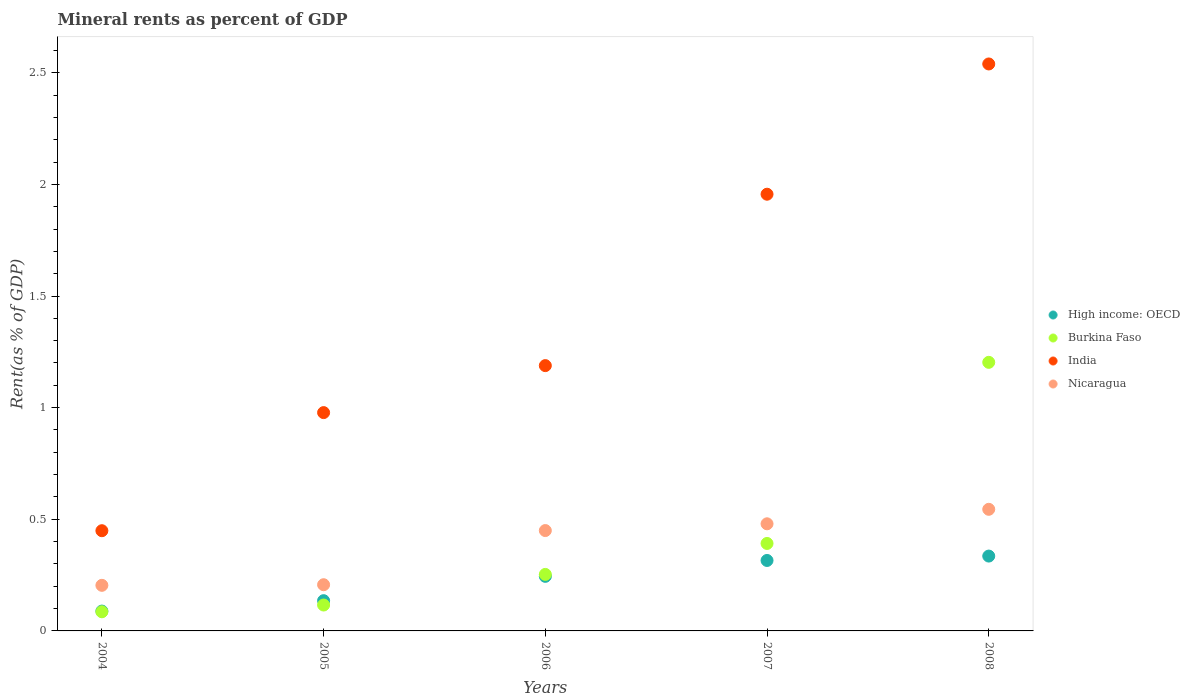Is the number of dotlines equal to the number of legend labels?
Ensure brevity in your answer.  Yes. What is the mineral rent in India in 2007?
Keep it short and to the point. 1.96. Across all years, what is the maximum mineral rent in Nicaragua?
Provide a short and direct response. 0.54. Across all years, what is the minimum mineral rent in High income: OECD?
Your answer should be very brief. 0.09. In which year was the mineral rent in India maximum?
Give a very brief answer. 2008. What is the total mineral rent in Nicaragua in the graph?
Offer a very short reply. 1.89. What is the difference between the mineral rent in High income: OECD in 2004 and that in 2008?
Offer a very short reply. -0.25. What is the difference between the mineral rent in Burkina Faso in 2004 and the mineral rent in Nicaragua in 2007?
Your answer should be very brief. -0.39. What is the average mineral rent in High income: OECD per year?
Make the answer very short. 0.22. In the year 2006, what is the difference between the mineral rent in Nicaragua and mineral rent in India?
Your answer should be compact. -0.74. In how many years, is the mineral rent in Nicaragua greater than 1.7 %?
Keep it short and to the point. 0. What is the ratio of the mineral rent in High income: OECD in 2004 to that in 2008?
Offer a very short reply. 0.27. Is the mineral rent in India in 2005 less than that in 2007?
Your answer should be very brief. Yes. What is the difference between the highest and the second highest mineral rent in Nicaragua?
Give a very brief answer. 0.06. What is the difference between the highest and the lowest mineral rent in High income: OECD?
Offer a terse response. 0.25. Is it the case that in every year, the sum of the mineral rent in Nicaragua and mineral rent in Burkina Faso  is greater than the mineral rent in India?
Provide a succinct answer. No. Does the mineral rent in India monotonically increase over the years?
Provide a succinct answer. Yes. Is the mineral rent in High income: OECD strictly less than the mineral rent in India over the years?
Keep it short and to the point. Yes. What is the difference between two consecutive major ticks on the Y-axis?
Offer a very short reply. 0.5. Are the values on the major ticks of Y-axis written in scientific E-notation?
Your answer should be compact. No. Where does the legend appear in the graph?
Your answer should be very brief. Center right. How many legend labels are there?
Offer a terse response. 4. How are the legend labels stacked?
Offer a terse response. Vertical. What is the title of the graph?
Your answer should be compact. Mineral rents as percent of GDP. What is the label or title of the X-axis?
Your answer should be compact. Years. What is the label or title of the Y-axis?
Provide a short and direct response. Rent(as % of GDP). What is the Rent(as % of GDP) in High income: OECD in 2004?
Keep it short and to the point. 0.09. What is the Rent(as % of GDP) in Burkina Faso in 2004?
Offer a terse response. 0.09. What is the Rent(as % of GDP) of India in 2004?
Your answer should be compact. 0.45. What is the Rent(as % of GDP) in Nicaragua in 2004?
Your response must be concise. 0.2. What is the Rent(as % of GDP) of High income: OECD in 2005?
Provide a short and direct response. 0.14. What is the Rent(as % of GDP) of Burkina Faso in 2005?
Offer a terse response. 0.12. What is the Rent(as % of GDP) of India in 2005?
Ensure brevity in your answer.  0.98. What is the Rent(as % of GDP) of Nicaragua in 2005?
Ensure brevity in your answer.  0.21. What is the Rent(as % of GDP) in High income: OECD in 2006?
Your answer should be compact. 0.24. What is the Rent(as % of GDP) in Burkina Faso in 2006?
Your response must be concise. 0.25. What is the Rent(as % of GDP) in India in 2006?
Offer a terse response. 1.19. What is the Rent(as % of GDP) of Nicaragua in 2006?
Your answer should be compact. 0.45. What is the Rent(as % of GDP) in High income: OECD in 2007?
Keep it short and to the point. 0.32. What is the Rent(as % of GDP) in Burkina Faso in 2007?
Make the answer very short. 0.39. What is the Rent(as % of GDP) in India in 2007?
Ensure brevity in your answer.  1.96. What is the Rent(as % of GDP) in Nicaragua in 2007?
Offer a terse response. 0.48. What is the Rent(as % of GDP) in High income: OECD in 2008?
Give a very brief answer. 0.34. What is the Rent(as % of GDP) in Burkina Faso in 2008?
Ensure brevity in your answer.  1.2. What is the Rent(as % of GDP) in India in 2008?
Make the answer very short. 2.54. What is the Rent(as % of GDP) of Nicaragua in 2008?
Offer a terse response. 0.54. Across all years, what is the maximum Rent(as % of GDP) in High income: OECD?
Provide a short and direct response. 0.34. Across all years, what is the maximum Rent(as % of GDP) of Burkina Faso?
Provide a short and direct response. 1.2. Across all years, what is the maximum Rent(as % of GDP) of India?
Make the answer very short. 2.54. Across all years, what is the maximum Rent(as % of GDP) of Nicaragua?
Your answer should be compact. 0.54. Across all years, what is the minimum Rent(as % of GDP) in High income: OECD?
Keep it short and to the point. 0.09. Across all years, what is the minimum Rent(as % of GDP) in Burkina Faso?
Offer a terse response. 0.09. Across all years, what is the minimum Rent(as % of GDP) of India?
Your answer should be very brief. 0.45. Across all years, what is the minimum Rent(as % of GDP) in Nicaragua?
Offer a terse response. 0.2. What is the total Rent(as % of GDP) of High income: OECD in the graph?
Provide a short and direct response. 1.12. What is the total Rent(as % of GDP) of Burkina Faso in the graph?
Give a very brief answer. 2.05. What is the total Rent(as % of GDP) of India in the graph?
Make the answer very short. 7.11. What is the total Rent(as % of GDP) in Nicaragua in the graph?
Your answer should be compact. 1.89. What is the difference between the Rent(as % of GDP) of High income: OECD in 2004 and that in 2005?
Offer a terse response. -0.05. What is the difference between the Rent(as % of GDP) in Burkina Faso in 2004 and that in 2005?
Provide a short and direct response. -0.03. What is the difference between the Rent(as % of GDP) of India in 2004 and that in 2005?
Keep it short and to the point. -0.53. What is the difference between the Rent(as % of GDP) in Nicaragua in 2004 and that in 2005?
Offer a terse response. -0. What is the difference between the Rent(as % of GDP) of High income: OECD in 2004 and that in 2006?
Keep it short and to the point. -0.16. What is the difference between the Rent(as % of GDP) of Burkina Faso in 2004 and that in 2006?
Provide a short and direct response. -0.17. What is the difference between the Rent(as % of GDP) in India in 2004 and that in 2006?
Make the answer very short. -0.74. What is the difference between the Rent(as % of GDP) in Nicaragua in 2004 and that in 2006?
Provide a succinct answer. -0.25. What is the difference between the Rent(as % of GDP) of High income: OECD in 2004 and that in 2007?
Your answer should be compact. -0.23. What is the difference between the Rent(as % of GDP) of Burkina Faso in 2004 and that in 2007?
Provide a succinct answer. -0.31. What is the difference between the Rent(as % of GDP) of India in 2004 and that in 2007?
Offer a terse response. -1.51. What is the difference between the Rent(as % of GDP) in Nicaragua in 2004 and that in 2007?
Your answer should be very brief. -0.28. What is the difference between the Rent(as % of GDP) of High income: OECD in 2004 and that in 2008?
Ensure brevity in your answer.  -0.25. What is the difference between the Rent(as % of GDP) of Burkina Faso in 2004 and that in 2008?
Your answer should be very brief. -1.12. What is the difference between the Rent(as % of GDP) in India in 2004 and that in 2008?
Provide a short and direct response. -2.09. What is the difference between the Rent(as % of GDP) in Nicaragua in 2004 and that in 2008?
Ensure brevity in your answer.  -0.34. What is the difference between the Rent(as % of GDP) in High income: OECD in 2005 and that in 2006?
Keep it short and to the point. -0.11. What is the difference between the Rent(as % of GDP) in Burkina Faso in 2005 and that in 2006?
Your answer should be compact. -0.14. What is the difference between the Rent(as % of GDP) of India in 2005 and that in 2006?
Your response must be concise. -0.21. What is the difference between the Rent(as % of GDP) in Nicaragua in 2005 and that in 2006?
Ensure brevity in your answer.  -0.24. What is the difference between the Rent(as % of GDP) of High income: OECD in 2005 and that in 2007?
Your answer should be compact. -0.18. What is the difference between the Rent(as % of GDP) of Burkina Faso in 2005 and that in 2007?
Your response must be concise. -0.28. What is the difference between the Rent(as % of GDP) in India in 2005 and that in 2007?
Offer a very short reply. -0.98. What is the difference between the Rent(as % of GDP) of Nicaragua in 2005 and that in 2007?
Your response must be concise. -0.27. What is the difference between the Rent(as % of GDP) in High income: OECD in 2005 and that in 2008?
Your response must be concise. -0.2. What is the difference between the Rent(as % of GDP) of Burkina Faso in 2005 and that in 2008?
Keep it short and to the point. -1.09. What is the difference between the Rent(as % of GDP) of India in 2005 and that in 2008?
Keep it short and to the point. -1.56. What is the difference between the Rent(as % of GDP) in Nicaragua in 2005 and that in 2008?
Keep it short and to the point. -0.34. What is the difference between the Rent(as % of GDP) of High income: OECD in 2006 and that in 2007?
Make the answer very short. -0.07. What is the difference between the Rent(as % of GDP) of Burkina Faso in 2006 and that in 2007?
Your answer should be compact. -0.14. What is the difference between the Rent(as % of GDP) in India in 2006 and that in 2007?
Your answer should be compact. -0.77. What is the difference between the Rent(as % of GDP) in Nicaragua in 2006 and that in 2007?
Ensure brevity in your answer.  -0.03. What is the difference between the Rent(as % of GDP) of High income: OECD in 2006 and that in 2008?
Make the answer very short. -0.09. What is the difference between the Rent(as % of GDP) in Burkina Faso in 2006 and that in 2008?
Keep it short and to the point. -0.95. What is the difference between the Rent(as % of GDP) in India in 2006 and that in 2008?
Your answer should be very brief. -1.35. What is the difference between the Rent(as % of GDP) in Nicaragua in 2006 and that in 2008?
Your answer should be very brief. -0.1. What is the difference between the Rent(as % of GDP) in High income: OECD in 2007 and that in 2008?
Your response must be concise. -0.02. What is the difference between the Rent(as % of GDP) of Burkina Faso in 2007 and that in 2008?
Give a very brief answer. -0.81. What is the difference between the Rent(as % of GDP) in India in 2007 and that in 2008?
Your response must be concise. -0.58. What is the difference between the Rent(as % of GDP) of Nicaragua in 2007 and that in 2008?
Provide a short and direct response. -0.06. What is the difference between the Rent(as % of GDP) in High income: OECD in 2004 and the Rent(as % of GDP) in Burkina Faso in 2005?
Your response must be concise. -0.03. What is the difference between the Rent(as % of GDP) of High income: OECD in 2004 and the Rent(as % of GDP) of India in 2005?
Keep it short and to the point. -0.89. What is the difference between the Rent(as % of GDP) of High income: OECD in 2004 and the Rent(as % of GDP) of Nicaragua in 2005?
Provide a short and direct response. -0.12. What is the difference between the Rent(as % of GDP) of Burkina Faso in 2004 and the Rent(as % of GDP) of India in 2005?
Your answer should be compact. -0.89. What is the difference between the Rent(as % of GDP) in Burkina Faso in 2004 and the Rent(as % of GDP) in Nicaragua in 2005?
Your answer should be compact. -0.12. What is the difference between the Rent(as % of GDP) of India in 2004 and the Rent(as % of GDP) of Nicaragua in 2005?
Your answer should be compact. 0.24. What is the difference between the Rent(as % of GDP) in High income: OECD in 2004 and the Rent(as % of GDP) in Burkina Faso in 2006?
Offer a very short reply. -0.16. What is the difference between the Rent(as % of GDP) of High income: OECD in 2004 and the Rent(as % of GDP) of India in 2006?
Offer a terse response. -1.1. What is the difference between the Rent(as % of GDP) in High income: OECD in 2004 and the Rent(as % of GDP) in Nicaragua in 2006?
Offer a terse response. -0.36. What is the difference between the Rent(as % of GDP) of Burkina Faso in 2004 and the Rent(as % of GDP) of India in 2006?
Provide a succinct answer. -1.1. What is the difference between the Rent(as % of GDP) in Burkina Faso in 2004 and the Rent(as % of GDP) in Nicaragua in 2006?
Give a very brief answer. -0.36. What is the difference between the Rent(as % of GDP) in India in 2004 and the Rent(as % of GDP) in Nicaragua in 2006?
Provide a succinct answer. -0. What is the difference between the Rent(as % of GDP) in High income: OECD in 2004 and the Rent(as % of GDP) in Burkina Faso in 2007?
Make the answer very short. -0.3. What is the difference between the Rent(as % of GDP) in High income: OECD in 2004 and the Rent(as % of GDP) in India in 2007?
Ensure brevity in your answer.  -1.87. What is the difference between the Rent(as % of GDP) in High income: OECD in 2004 and the Rent(as % of GDP) in Nicaragua in 2007?
Keep it short and to the point. -0.39. What is the difference between the Rent(as % of GDP) in Burkina Faso in 2004 and the Rent(as % of GDP) in India in 2007?
Keep it short and to the point. -1.87. What is the difference between the Rent(as % of GDP) in Burkina Faso in 2004 and the Rent(as % of GDP) in Nicaragua in 2007?
Offer a very short reply. -0.39. What is the difference between the Rent(as % of GDP) of India in 2004 and the Rent(as % of GDP) of Nicaragua in 2007?
Your answer should be compact. -0.03. What is the difference between the Rent(as % of GDP) of High income: OECD in 2004 and the Rent(as % of GDP) of Burkina Faso in 2008?
Offer a terse response. -1.11. What is the difference between the Rent(as % of GDP) in High income: OECD in 2004 and the Rent(as % of GDP) in India in 2008?
Provide a succinct answer. -2.45. What is the difference between the Rent(as % of GDP) in High income: OECD in 2004 and the Rent(as % of GDP) in Nicaragua in 2008?
Keep it short and to the point. -0.46. What is the difference between the Rent(as % of GDP) of Burkina Faso in 2004 and the Rent(as % of GDP) of India in 2008?
Provide a short and direct response. -2.45. What is the difference between the Rent(as % of GDP) of Burkina Faso in 2004 and the Rent(as % of GDP) of Nicaragua in 2008?
Your answer should be very brief. -0.46. What is the difference between the Rent(as % of GDP) in India in 2004 and the Rent(as % of GDP) in Nicaragua in 2008?
Your answer should be very brief. -0.1. What is the difference between the Rent(as % of GDP) in High income: OECD in 2005 and the Rent(as % of GDP) in Burkina Faso in 2006?
Keep it short and to the point. -0.12. What is the difference between the Rent(as % of GDP) of High income: OECD in 2005 and the Rent(as % of GDP) of India in 2006?
Offer a very short reply. -1.05. What is the difference between the Rent(as % of GDP) in High income: OECD in 2005 and the Rent(as % of GDP) in Nicaragua in 2006?
Provide a succinct answer. -0.31. What is the difference between the Rent(as % of GDP) in Burkina Faso in 2005 and the Rent(as % of GDP) in India in 2006?
Your answer should be very brief. -1.07. What is the difference between the Rent(as % of GDP) of Burkina Faso in 2005 and the Rent(as % of GDP) of Nicaragua in 2006?
Provide a succinct answer. -0.33. What is the difference between the Rent(as % of GDP) of India in 2005 and the Rent(as % of GDP) of Nicaragua in 2006?
Give a very brief answer. 0.53. What is the difference between the Rent(as % of GDP) of High income: OECD in 2005 and the Rent(as % of GDP) of Burkina Faso in 2007?
Make the answer very short. -0.26. What is the difference between the Rent(as % of GDP) in High income: OECD in 2005 and the Rent(as % of GDP) in India in 2007?
Give a very brief answer. -1.82. What is the difference between the Rent(as % of GDP) of High income: OECD in 2005 and the Rent(as % of GDP) of Nicaragua in 2007?
Offer a terse response. -0.34. What is the difference between the Rent(as % of GDP) in Burkina Faso in 2005 and the Rent(as % of GDP) in India in 2007?
Your answer should be very brief. -1.84. What is the difference between the Rent(as % of GDP) in Burkina Faso in 2005 and the Rent(as % of GDP) in Nicaragua in 2007?
Your answer should be very brief. -0.36. What is the difference between the Rent(as % of GDP) of India in 2005 and the Rent(as % of GDP) of Nicaragua in 2007?
Provide a succinct answer. 0.5. What is the difference between the Rent(as % of GDP) of High income: OECD in 2005 and the Rent(as % of GDP) of Burkina Faso in 2008?
Keep it short and to the point. -1.07. What is the difference between the Rent(as % of GDP) in High income: OECD in 2005 and the Rent(as % of GDP) in India in 2008?
Offer a very short reply. -2.4. What is the difference between the Rent(as % of GDP) of High income: OECD in 2005 and the Rent(as % of GDP) of Nicaragua in 2008?
Ensure brevity in your answer.  -0.41. What is the difference between the Rent(as % of GDP) in Burkina Faso in 2005 and the Rent(as % of GDP) in India in 2008?
Provide a short and direct response. -2.42. What is the difference between the Rent(as % of GDP) of Burkina Faso in 2005 and the Rent(as % of GDP) of Nicaragua in 2008?
Keep it short and to the point. -0.43. What is the difference between the Rent(as % of GDP) in India in 2005 and the Rent(as % of GDP) in Nicaragua in 2008?
Your response must be concise. 0.43. What is the difference between the Rent(as % of GDP) of High income: OECD in 2006 and the Rent(as % of GDP) of Burkina Faso in 2007?
Your answer should be very brief. -0.15. What is the difference between the Rent(as % of GDP) of High income: OECD in 2006 and the Rent(as % of GDP) of India in 2007?
Make the answer very short. -1.71. What is the difference between the Rent(as % of GDP) in High income: OECD in 2006 and the Rent(as % of GDP) in Nicaragua in 2007?
Your answer should be compact. -0.24. What is the difference between the Rent(as % of GDP) in Burkina Faso in 2006 and the Rent(as % of GDP) in India in 2007?
Your answer should be very brief. -1.7. What is the difference between the Rent(as % of GDP) of Burkina Faso in 2006 and the Rent(as % of GDP) of Nicaragua in 2007?
Your answer should be compact. -0.23. What is the difference between the Rent(as % of GDP) in India in 2006 and the Rent(as % of GDP) in Nicaragua in 2007?
Give a very brief answer. 0.71. What is the difference between the Rent(as % of GDP) of High income: OECD in 2006 and the Rent(as % of GDP) of Burkina Faso in 2008?
Provide a short and direct response. -0.96. What is the difference between the Rent(as % of GDP) in High income: OECD in 2006 and the Rent(as % of GDP) in India in 2008?
Your response must be concise. -2.29. What is the difference between the Rent(as % of GDP) of High income: OECD in 2006 and the Rent(as % of GDP) of Nicaragua in 2008?
Provide a succinct answer. -0.3. What is the difference between the Rent(as % of GDP) in Burkina Faso in 2006 and the Rent(as % of GDP) in India in 2008?
Your answer should be very brief. -2.29. What is the difference between the Rent(as % of GDP) in Burkina Faso in 2006 and the Rent(as % of GDP) in Nicaragua in 2008?
Make the answer very short. -0.29. What is the difference between the Rent(as % of GDP) of India in 2006 and the Rent(as % of GDP) of Nicaragua in 2008?
Provide a succinct answer. 0.64. What is the difference between the Rent(as % of GDP) of High income: OECD in 2007 and the Rent(as % of GDP) of Burkina Faso in 2008?
Your answer should be very brief. -0.89. What is the difference between the Rent(as % of GDP) of High income: OECD in 2007 and the Rent(as % of GDP) of India in 2008?
Give a very brief answer. -2.22. What is the difference between the Rent(as % of GDP) in High income: OECD in 2007 and the Rent(as % of GDP) in Nicaragua in 2008?
Offer a terse response. -0.23. What is the difference between the Rent(as % of GDP) in Burkina Faso in 2007 and the Rent(as % of GDP) in India in 2008?
Provide a short and direct response. -2.15. What is the difference between the Rent(as % of GDP) of Burkina Faso in 2007 and the Rent(as % of GDP) of Nicaragua in 2008?
Provide a succinct answer. -0.15. What is the difference between the Rent(as % of GDP) of India in 2007 and the Rent(as % of GDP) of Nicaragua in 2008?
Your answer should be very brief. 1.41. What is the average Rent(as % of GDP) in High income: OECD per year?
Give a very brief answer. 0.22. What is the average Rent(as % of GDP) of Burkina Faso per year?
Give a very brief answer. 0.41. What is the average Rent(as % of GDP) of India per year?
Offer a very short reply. 1.42. What is the average Rent(as % of GDP) in Nicaragua per year?
Provide a short and direct response. 0.38. In the year 2004, what is the difference between the Rent(as % of GDP) in High income: OECD and Rent(as % of GDP) in Burkina Faso?
Provide a short and direct response. 0. In the year 2004, what is the difference between the Rent(as % of GDP) in High income: OECD and Rent(as % of GDP) in India?
Provide a short and direct response. -0.36. In the year 2004, what is the difference between the Rent(as % of GDP) in High income: OECD and Rent(as % of GDP) in Nicaragua?
Ensure brevity in your answer.  -0.12. In the year 2004, what is the difference between the Rent(as % of GDP) in Burkina Faso and Rent(as % of GDP) in India?
Give a very brief answer. -0.36. In the year 2004, what is the difference between the Rent(as % of GDP) of Burkina Faso and Rent(as % of GDP) of Nicaragua?
Make the answer very short. -0.12. In the year 2004, what is the difference between the Rent(as % of GDP) of India and Rent(as % of GDP) of Nicaragua?
Offer a very short reply. 0.24. In the year 2005, what is the difference between the Rent(as % of GDP) of High income: OECD and Rent(as % of GDP) of Burkina Faso?
Your answer should be compact. 0.02. In the year 2005, what is the difference between the Rent(as % of GDP) in High income: OECD and Rent(as % of GDP) in India?
Ensure brevity in your answer.  -0.84. In the year 2005, what is the difference between the Rent(as % of GDP) in High income: OECD and Rent(as % of GDP) in Nicaragua?
Keep it short and to the point. -0.07. In the year 2005, what is the difference between the Rent(as % of GDP) in Burkina Faso and Rent(as % of GDP) in India?
Make the answer very short. -0.86. In the year 2005, what is the difference between the Rent(as % of GDP) of Burkina Faso and Rent(as % of GDP) of Nicaragua?
Offer a terse response. -0.09. In the year 2005, what is the difference between the Rent(as % of GDP) in India and Rent(as % of GDP) in Nicaragua?
Your answer should be compact. 0.77. In the year 2006, what is the difference between the Rent(as % of GDP) in High income: OECD and Rent(as % of GDP) in Burkina Faso?
Offer a very short reply. -0.01. In the year 2006, what is the difference between the Rent(as % of GDP) of High income: OECD and Rent(as % of GDP) of India?
Ensure brevity in your answer.  -0.94. In the year 2006, what is the difference between the Rent(as % of GDP) in High income: OECD and Rent(as % of GDP) in Nicaragua?
Make the answer very short. -0.2. In the year 2006, what is the difference between the Rent(as % of GDP) of Burkina Faso and Rent(as % of GDP) of India?
Provide a succinct answer. -0.94. In the year 2006, what is the difference between the Rent(as % of GDP) in Burkina Faso and Rent(as % of GDP) in Nicaragua?
Provide a succinct answer. -0.2. In the year 2006, what is the difference between the Rent(as % of GDP) in India and Rent(as % of GDP) in Nicaragua?
Provide a succinct answer. 0.74. In the year 2007, what is the difference between the Rent(as % of GDP) in High income: OECD and Rent(as % of GDP) in Burkina Faso?
Your answer should be compact. -0.08. In the year 2007, what is the difference between the Rent(as % of GDP) in High income: OECD and Rent(as % of GDP) in India?
Ensure brevity in your answer.  -1.64. In the year 2007, what is the difference between the Rent(as % of GDP) of High income: OECD and Rent(as % of GDP) of Nicaragua?
Make the answer very short. -0.16. In the year 2007, what is the difference between the Rent(as % of GDP) in Burkina Faso and Rent(as % of GDP) in India?
Provide a short and direct response. -1.56. In the year 2007, what is the difference between the Rent(as % of GDP) in Burkina Faso and Rent(as % of GDP) in Nicaragua?
Your answer should be compact. -0.09. In the year 2007, what is the difference between the Rent(as % of GDP) in India and Rent(as % of GDP) in Nicaragua?
Ensure brevity in your answer.  1.48. In the year 2008, what is the difference between the Rent(as % of GDP) in High income: OECD and Rent(as % of GDP) in Burkina Faso?
Your answer should be very brief. -0.87. In the year 2008, what is the difference between the Rent(as % of GDP) of High income: OECD and Rent(as % of GDP) of India?
Your answer should be compact. -2.2. In the year 2008, what is the difference between the Rent(as % of GDP) of High income: OECD and Rent(as % of GDP) of Nicaragua?
Make the answer very short. -0.21. In the year 2008, what is the difference between the Rent(as % of GDP) in Burkina Faso and Rent(as % of GDP) in India?
Keep it short and to the point. -1.34. In the year 2008, what is the difference between the Rent(as % of GDP) of Burkina Faso and Rent(as % of GDP) of Nicaragua?
Provide a short and direct response. 0.66. In the year 2008, what is the difference between the Rent(as % of GDP) in India and Rent(as % of GDP) in Nicaragua?
Your answer should be very brief. 1.99. What is the ratio of the Rent(as % of GDP) of High income: OECD in 2004 to that in 2005?
Give a very brief answer. 0.66. What is the ratio of the Rent(as % of GDP) of Burkina Faso in 2004 to that in 2005?
Keep it short and to the point. 0.74. What is the ratio of the Rent(as % of GDP) in India in 2004 to that in 2005?
Offer a terse response. 0.46. What is the ratio of the Rent(as % of GDP) of Nicaragua in 2004 to that in 2005?
Keep it short and to the point. 0.99. What is the ratio of the Rent(as % of GDP) of High income: OECD in 2004 to that in 2006?
Make the answer very short. 0.36. What is the ratio of the Rent(as % of GDP) in Burkina Faso in 2004 to that in 2006?
Offer a very short reply. 0.34. What is the ratio of the Rent(as % of GDP) in India in 2004 to that in 2006?
Provide a succinct answer. 0.38. What is the ratio of the Rent(as % of GDP) of Nicaragua in 2004 to that in 2006?
Offer a very short reply. 0.45. What is the ratio of the Rent(as % of GDP) of High income: OECD in 2004 to that in 2007?
Make the answer very short. 0.28. What is the ratio of the Rent(as % of GDP) in Burkina Faso in 2004 to that in 2007?
Ensure brevity in your answer.  0.22. What is the ratio of the Rent(as % of GDP) in India in 2004 to that in 2007?
Give a very brief answer. 0.23. What is the ratio of the Rent(as % of GDP) in Nicaragua in 2004 to that in 2007?
Provide a short and direct response. 0.43. What is the ratio of the Rent(as % of GDP) of High income: OECD in 2004 to that in 2008?
Make the answer very short. 0.27. What is the ratio of the Rent(as % of GDP) of Burkina Faso in 2004 to that in 2008?
Provide a short and direct response. 0.07. What is the ratio of the Rent(as % of GDP) of India in 2004 to that in 2008?
Make the answer very short. 0.18. What is the ratio of the Rent(as % of GDP) in Nicaragua in 2004 to that in 2008?
Offer a very short reply. 0.37. What is the ratio of the Rent(as % of GDP) of High income: OECD in 2005 to that in 2006?
Offer a very short reply. 0.55. What is the ratio of the Rent(as % of GDP) in Burkina Faso in 2005 to that in 2006?
Your answer should be compact. 0.46. What is the ratio of the Rent(as % of GDP) in India in 2005 to that in 2006?
Your response must be concise. 0.82. What is the ratio of the Rent(as % of GDP) of Nicaragua in 2005 to that in 2006?
Your response must be concise. 0.46. What is the ratio of the Rent(as % of GDP) in High income: OECD in 2005 to that in 2007?
Your response must be concise. 0.43. What is the ratio of the Rent(as % of GDP) of Burkina Faso in 2005 to that in 2007?
Your answer should be very brief. 0.3. What is the ratio of the Rent(as % of GDP) of India in 2005 to that in 2007?
Ensure brevity in your answer.  0.5. What is the ratio of the Rent(as % of GDP) of Nicaragua in 2005 to that in 2007?
Offer a very short reply. 0.43. What is the ratio of the Rent(as % of GDP) in High income: OECD in 2005 to that in 2008?
Ensure brevity in your answer.  0.4. What is the ratio of the Rent(as % of GDP) of Burkina Faso in 2005 to that in 2008?
Your response must be concise. 0.1. What is the ratio of the Rent(as % of GDP) of India in 2005 to that in 2008?
Make the answer very short. 0.39. What is the ratio of the Rent(as % of GDP) of Nicaragua in 2005 to that in 2008?
Give a very brief answer. 0.38. What is the ratio of the Rent(as % of GDP) of High income: OECD in 2006 to that in 2007?
Your answer should be compact. 0.77. What is the ratio of the Rent(as % of GDP) in Burkina Faso in 2006 to that in 2007?
Ensure brevity in your answer.  0.65. What is the ratio of the Rent(as % of GDP) in India in 2006 to that in 2007?
Your answer should be very brief. 0.61. What is the ratio of the Rent(as % of GDP) in Nicaragua in 2006 to that in 2007?
Provide a succinct answer. 0.94. What is the ratio of the Rent(as % of GDP) of High income: OECD in 2006 to that in 2008?
Your response must be concise. 0.73. What is the ratio of the Rent(as % of GDP) in Burkina Faso in 2006 to that in 2008?
Your answer should be compact. 0.21. What is the ratio of the Rent(as % of GDP) of India in 2006 to that in 2008?
Give a very brief answer. 0.47. What is the ratio of the Rent(as % of GDP) of Nicaragua in 2006 to that in 2008?
Provide a succinct answer. 0.83. What is the ratio of the Rent(as % of GDP) in High income: OECD in 2007 to that in 2008?
Offer a very short reply. 0.94. What is the ratio of the Rent(as % of GDP) in Burkina Faso in 2007 to that in 2008?
Keep it short and to the point. 0.33. What is the ratio of the Rent(as % of GDP) in India in 2007 to that in 2008?
Your answer should be very brief. 0.77. What is the ratio of the Rent(as % of GDP) in Nicaragua in 2007 to that in 2008?
Make the answer very short. 0.88. What is the difference between the highest and the second highest Rent(as % of GDP) in High income: OECD?
Offer a terse response. 0.02. What is the difference between the highest and the second highest Rent(as % of GDP) of Burkina Faso?
Provide a succinct answer. 0.81. What is the difference between the highest and the second highest Rent(as % of GDP) in India?
Your answer should be compact. 0.58. What is the difference between the highest and the second highest Rent(as % of GDP) of Nicaragua?
Offer a very short reply. 0.06. What is the difference between the highest and the lowest Rent(as % of GDP) of High income: OECD?
Offer a terse response. 0.25. What is the difference between the highest and the lowest Rent(as % of GDP) in Burkina Faso?
Offer a terse response. 1.12. What is the difference between the highest and the lowest Rent(as % of GDP) in India?
Your answer should be very brief. 2.09. What is the difference between the highest and the lowest Rent(as % of GDP) in Nicaragua?
Provide a short and direct response. 0.34. 